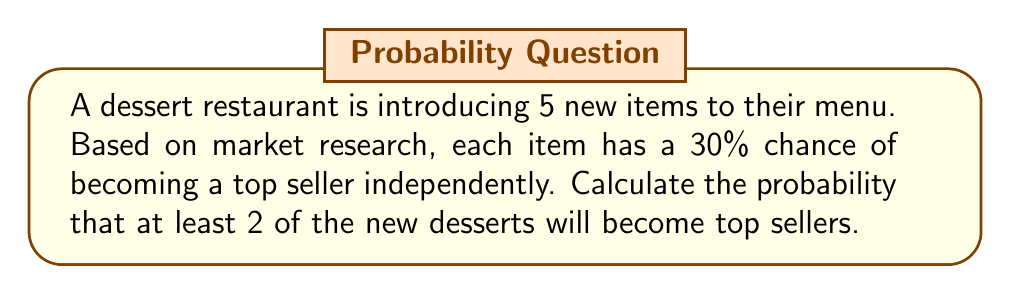Show me your answer to this math problem. Let's approach this step-by-step:

1) This is a binomial probability problem. We need to find P(X ≥ 2), where X is the number of top sellers.

2) The probability of success (p) = 0.30
   The number of trials (n) = 5
   We need to find P(X ≥ 2) = 1 - P(X < 2) = 1 - [P(X = 0) + P(X = 1)]

3) The binomial probability formula is:

   $$P(X = k) = \binom{n}{k} p^k (1-p)^{n-k}$$

4) Let's calculate P(X = 0):
   $$P(X = 0) = \binom{5}{0} (0.30)^0 (0.70)^5 = 1 \cdot 1 \cdot 0.16807 = 0.16807$$

5) Now, let's calculate P(X = 1):
   $$P(X = 1) = \binom{5}{1} (0.30)^1 (0.70)^4 = 5 \cdot 0.30 \cdot 0.2401 = 0.36015$$

6) Therefore, P(X < 2) = P(X = 0) + P(X = 1) = 0.16807 + 0.36015 = 0.52822

7) Finally, P(X ≥ 2) = 1 - P(X < 2) = 1 - 0.52822 = 0.47178
Answer: 0.47178 